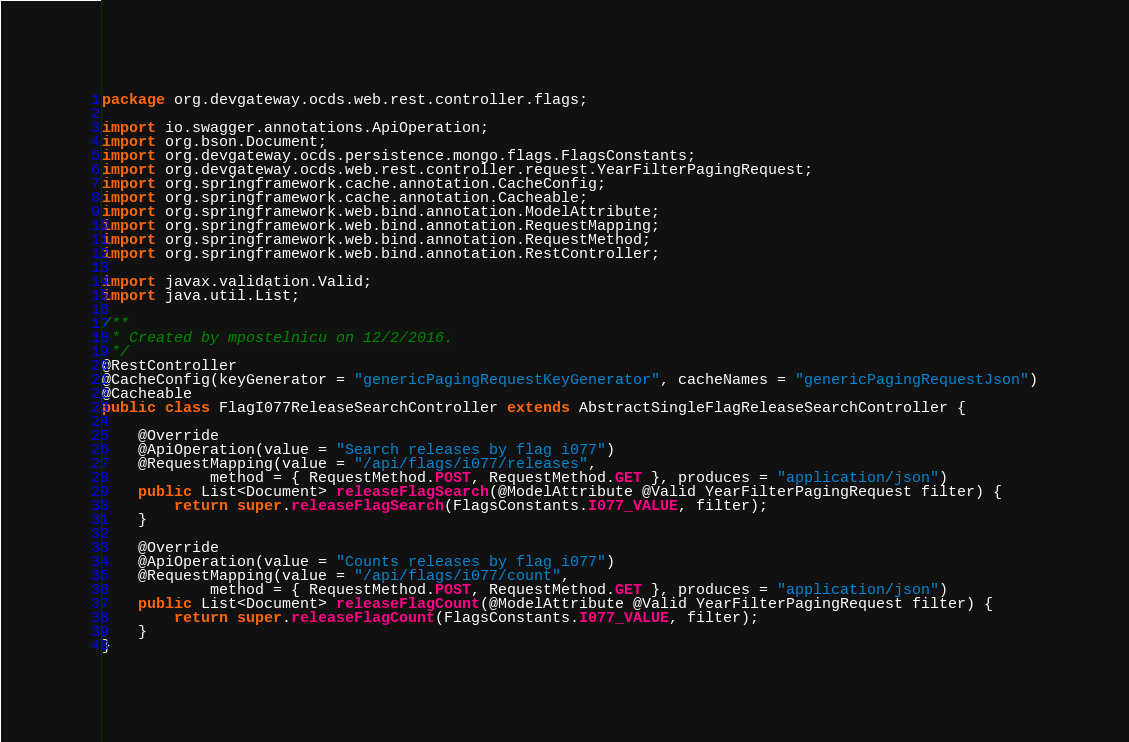<code> <loc_0><loc_0><loc_500><loc_500><_Java_>package org.devgateway.ocds.web.rest.controller.flags;

import io.swagger.annotations.ApiOperation;
import org.bson.Document;
import org.devgateway.ocds.persistence.mongo.flags.FlagsConstants;
import org.devgateway.ocds.web.rest.controller.request.YearFilterPagingRequest;
import org.springframework.cache.annotation.CacheConfig;
import org.springframework.cache.annotation.Cacheable;
import org.springframework.web.bind.annotation.ModelAttribute;
import org.springframework.web.bind.annotation.RequestMapping;
import org.springframework.web.bind.annotation.RequestMethod;
import org.springframework.web.bind.annotation.RestController;

import javax.validation.Valid;
import java.util.List;

/**
 * Created by mpostelnicu on 12/2/2016.
 */
@RestController
@CacheConfig(keyGenerator = "genericPagingRequestKeyGenerator", cacheNames = "genericPagingRequestJson")
@Cacheable
public class FlagI077ReleaseSearchController extends AbstractSingleFlagReleaseSearchController {

    @Override
    @ApiOperation(value = "Search releases by flag i077")
    @RequestMapping(value = "/api/flags/i077/releases",
            method = { RequestMethod.POST, RequestMethod.GET }, produces = "application/json")
    public List<Document> releaseFlagSearch(@ModelAttribute @Valid YearFilterPagingRequest filter) {
        return super.releaseFlagSearch(FlagsConstants.I077_VALUE, filter);
    }

    @Override
    @ApiOperation(value = "Counts releases by flag i077")
    @RequestMapping(value = "/api/flags/i077/count",
            method = { RequestMethod.POST, RequestMethod.GET }, produces = "application/json")
    public List<Document> releaseFlagCount(@ModelAttribute @Valid YearFilterPagingRequest filter) {
        return super.releaseFlagCount(FlagsConstants.I077_VALUE, filter);
    }
}
</code> 